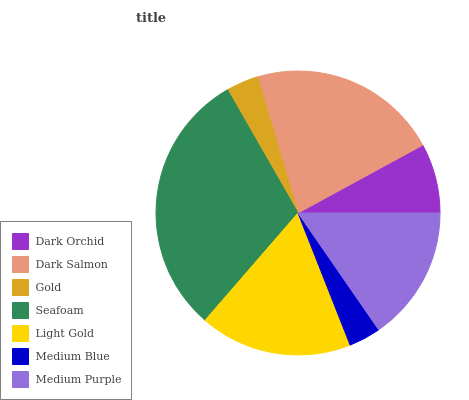Is Medium Blue the minimum?
Answer yes or no. Yes. Is Seafoam the maximum?
Answer yes or no. Yes. Is Dark Salmon the minimum?
Answer yes or no. No. Is Dark Salmon the maximum?
Answer yes or no. No. Is Dark Salmon greater than Dark Orchid?
Answer yes or no. Yes. Is Dark Orchid less than Dark Salmon?
Answer yes or no. Yes. Is Dark Orchid greater than Dark Salmon?
Answer yes or no. No. Is Dark Salmon less than Dark Orchid?
Answer yes or no. No. Is Medium Purple the high median?
Answer yes or no. Yes. Is Medium Purple the low median?
Answer yes or no. Yes. Is Dark Orchid the high median?
Answer yes or no. No. Is Dark Orchid the low median?
Answer yes or no. No. 